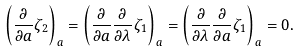<formula> <loc_0><loc_0><loc_500><loc_500>\left ( \frac { \partial } { \partial a } \zeta _ { 2 } \right ) _ { a } = \left ( \frac { \partial } { \partial a } \frac { \partial } { \partial \lambda } \zeta _ { 1 } \right ) _ { a } = \left ( \frac { \partial } { \partial \lambda } \frac { \partial } { \partial a } \zeta _ { 1 } \right ) _ { a } = 0 .</formula> 